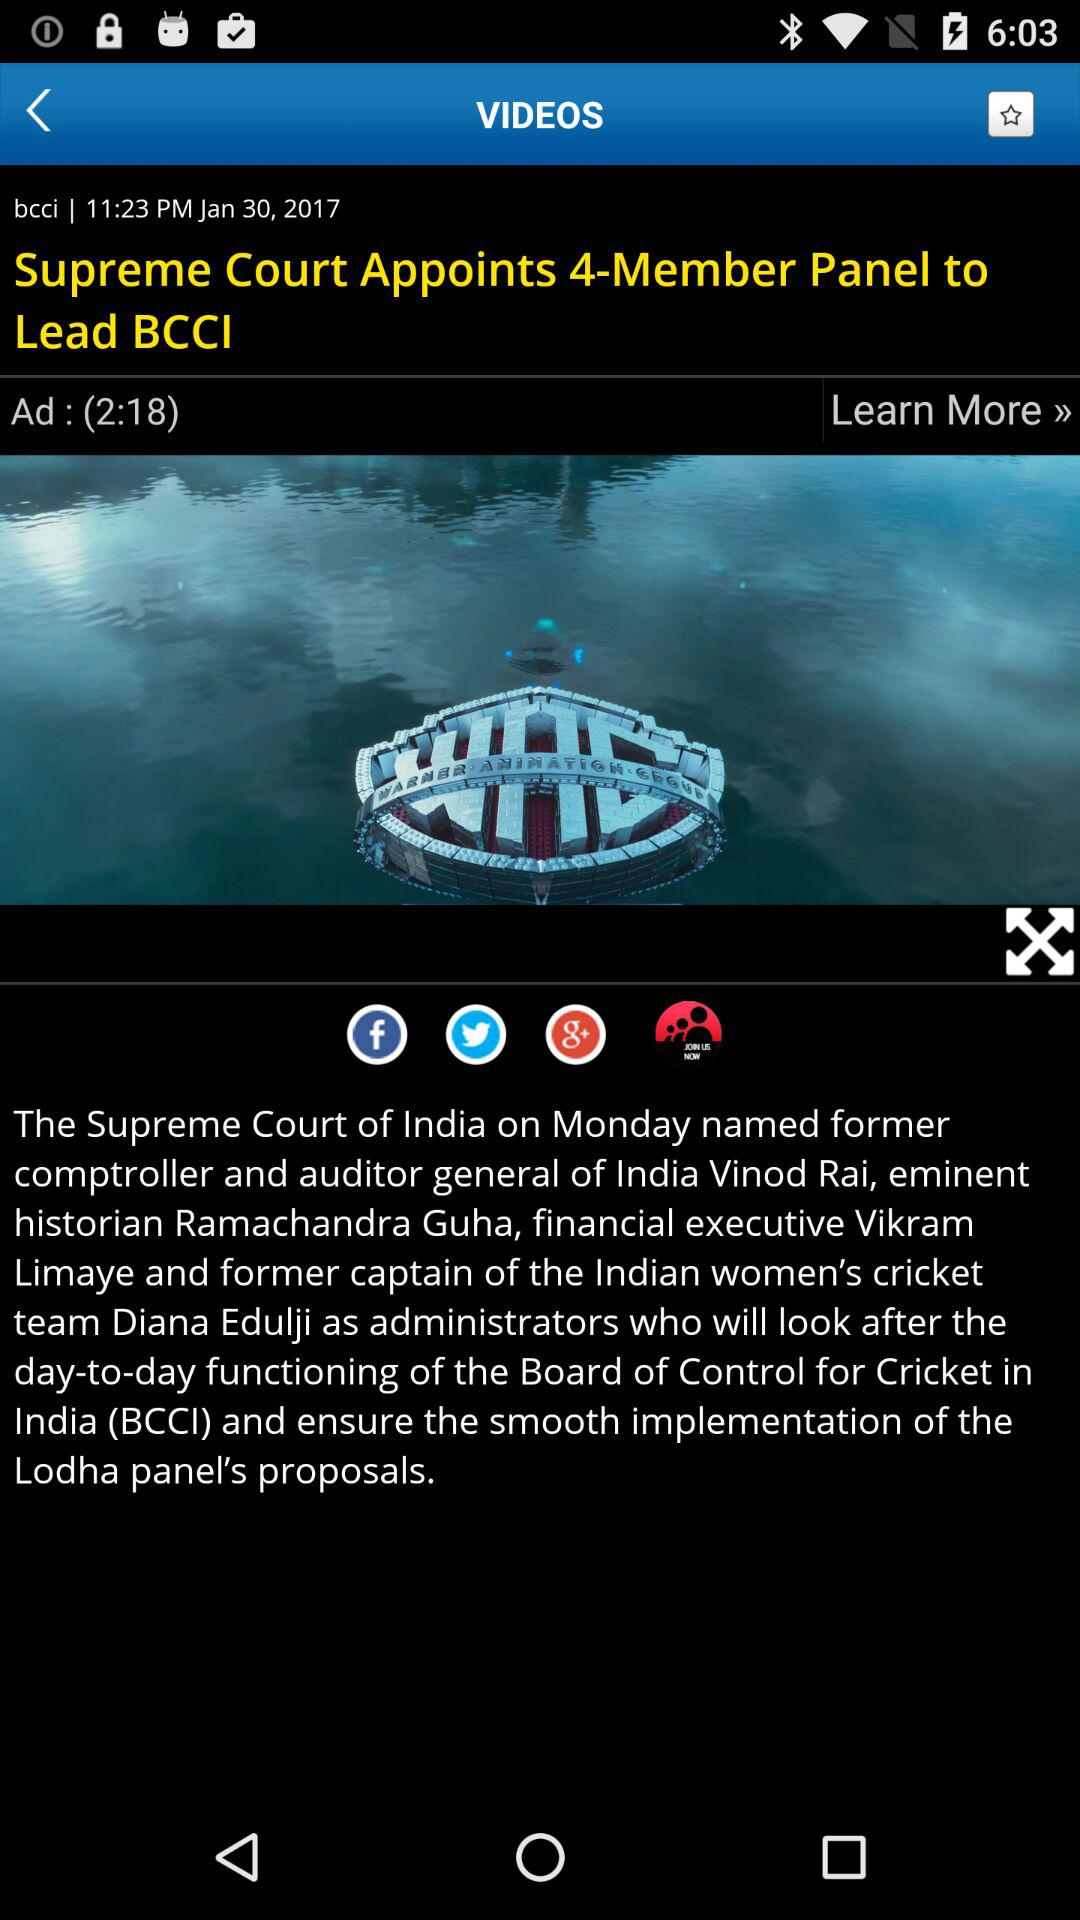Who is the former captain of the Indian women's cricket team? The former captain of the Indian women's cricket team is Vikram Limaye. 